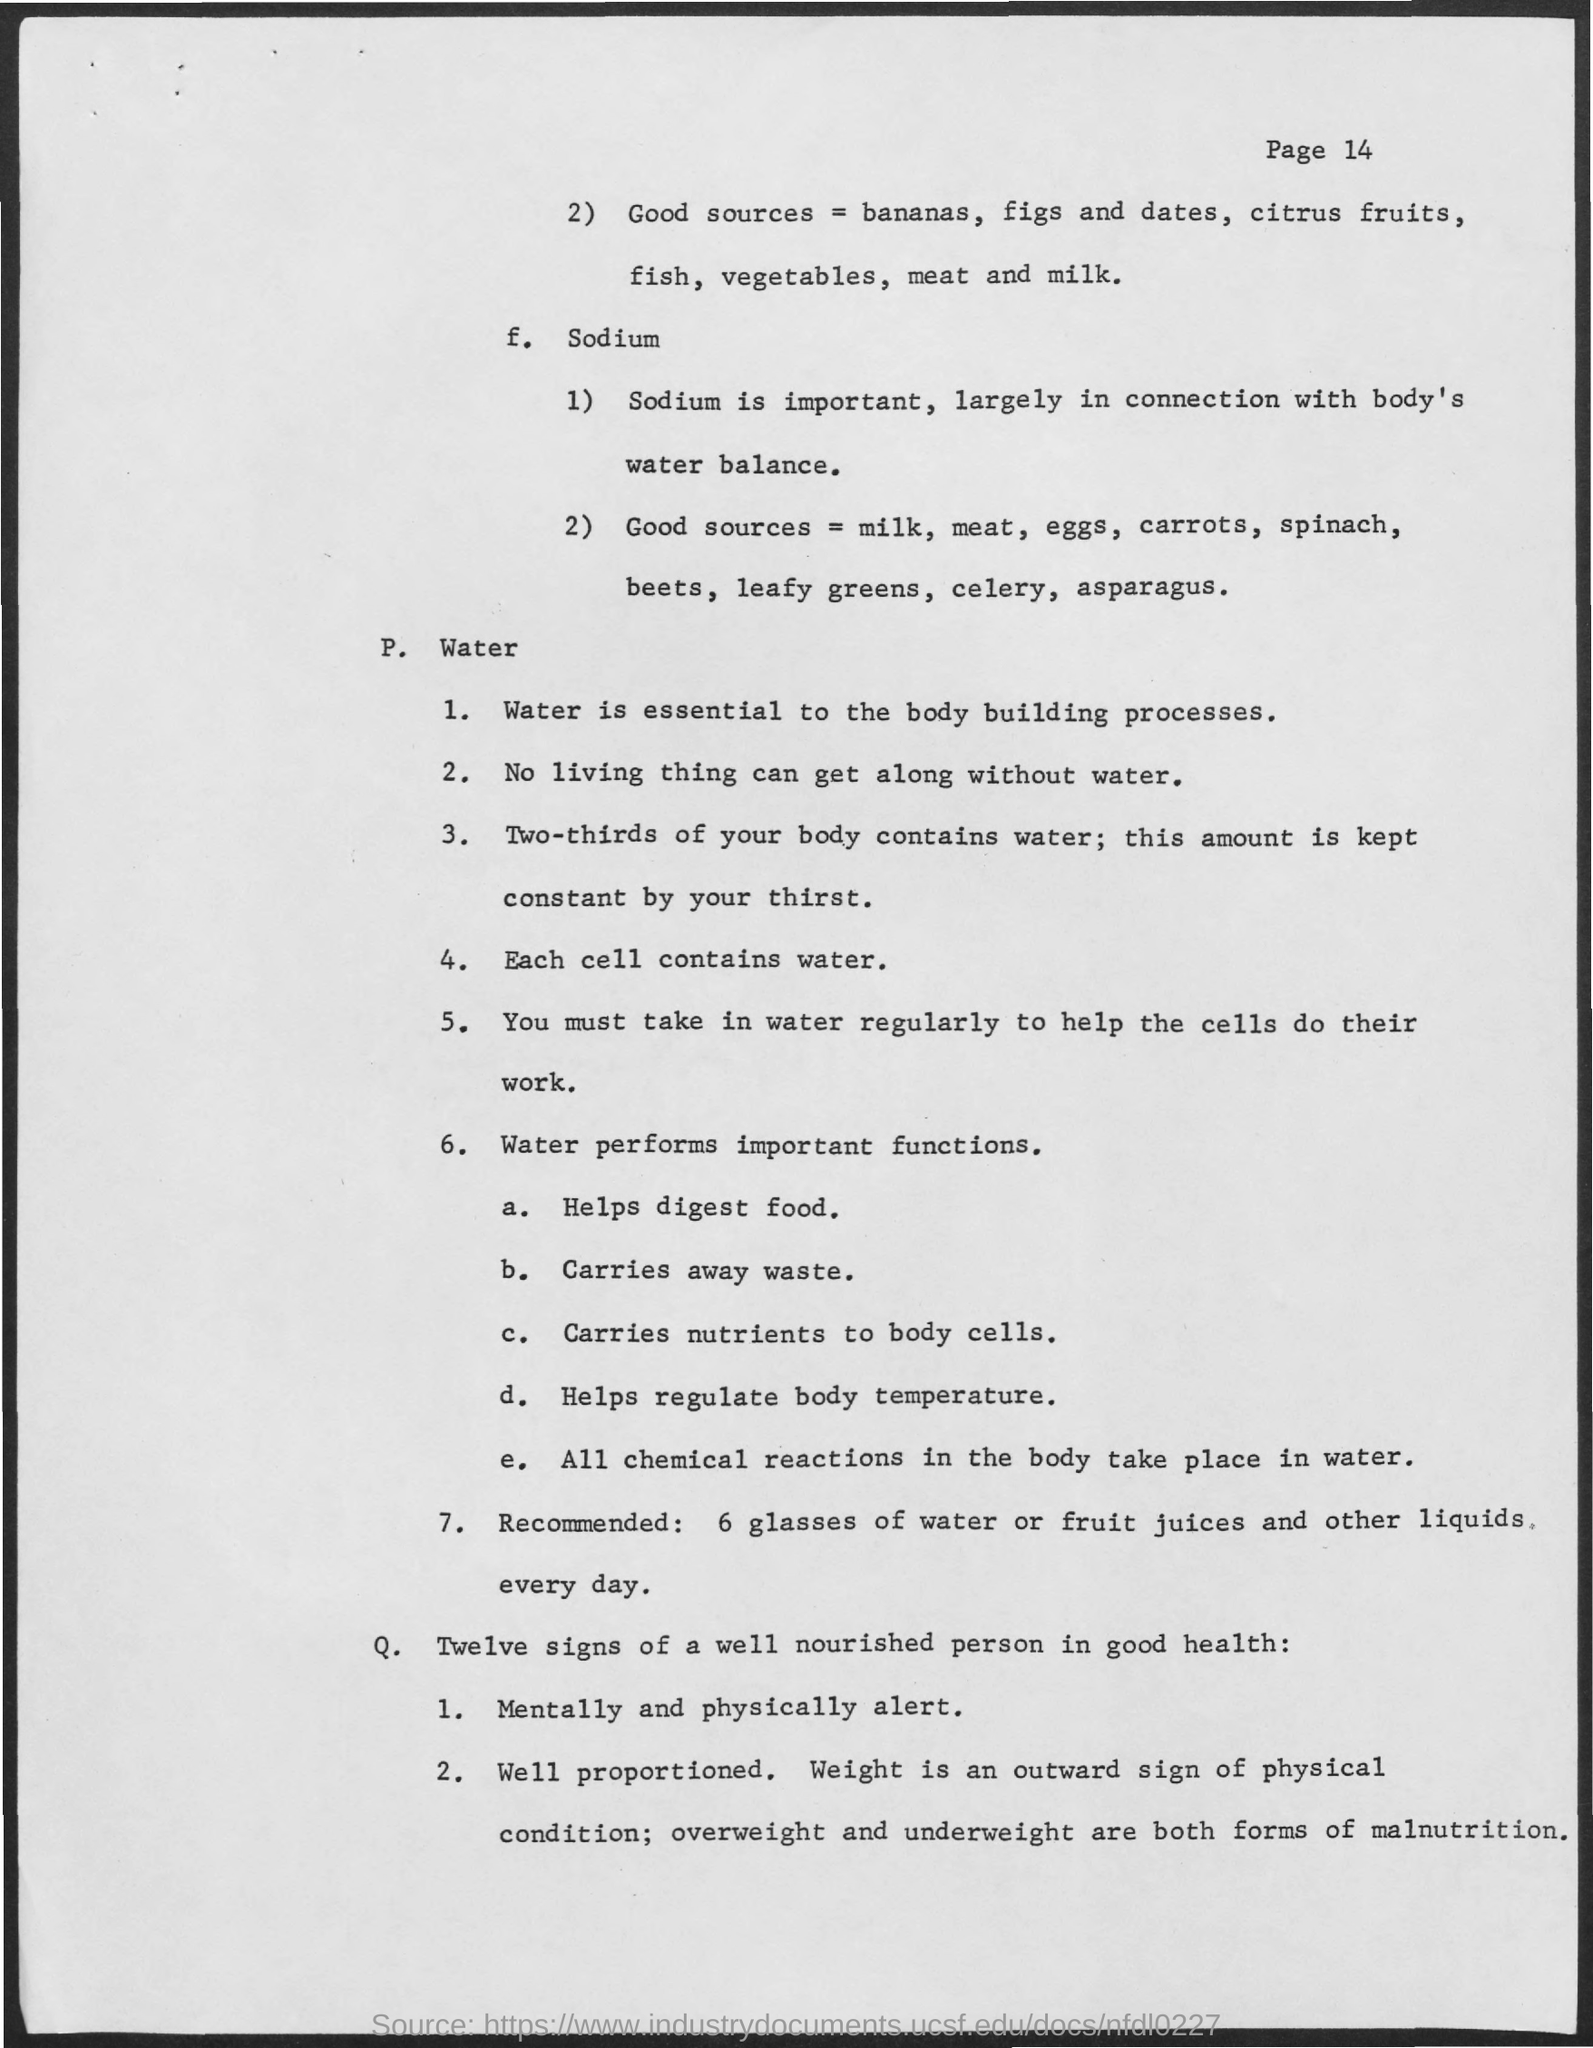Why sodium is important ?
Provide a succinct answer. Largely in connection with body's water balance. What does two third of our body contains ?
Ensure brevity in your answer.  WATER. What does each cell contain ?
Your response must be concise. Water. 